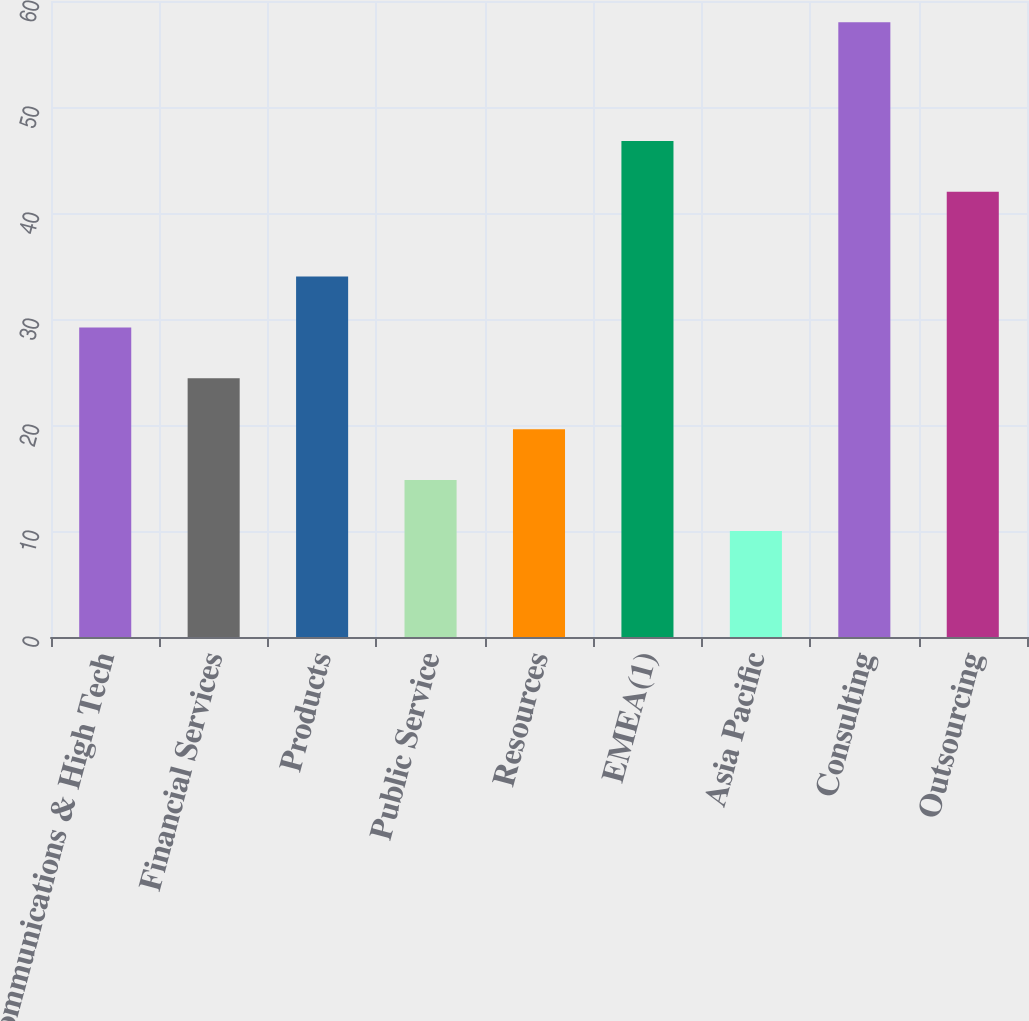Convert chart. <chart><loc_0><loc_0><loc_500><loc_500><bar_chart><fcel>Communications & High Tech<fcel>Financial Services<fcel>Products<fcel>Public Service<fcel>Resources<fcel>EMEA(1)<fcel>Asia Pacific<fcel>Consulting<fcel>Outsourcing<nl><fcel>29.2<fcel>24.4<fcel>34<fcel>14.8<fcel>19.6<fcel>46.8<fcel>10<fcel>58<fcel>42<nl></chart> 